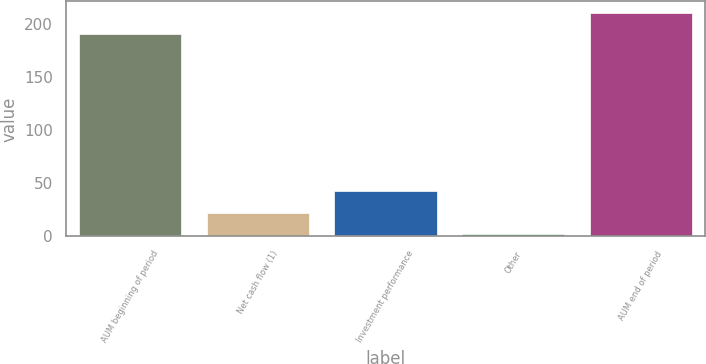Convert chart to OTSL. <chart><loc_0><loc_0><loc_500><loc_500><bar_chart><fcel>AUM beginning of period<fcel>Net cash flow (1)<fcel>Investment performance<fcel>Other<fcel>AUM end of period<nl><fcel>190<fcel>22.06<fcel>42.42<fcel>1.7<fcel>210.36<nl></chart> 